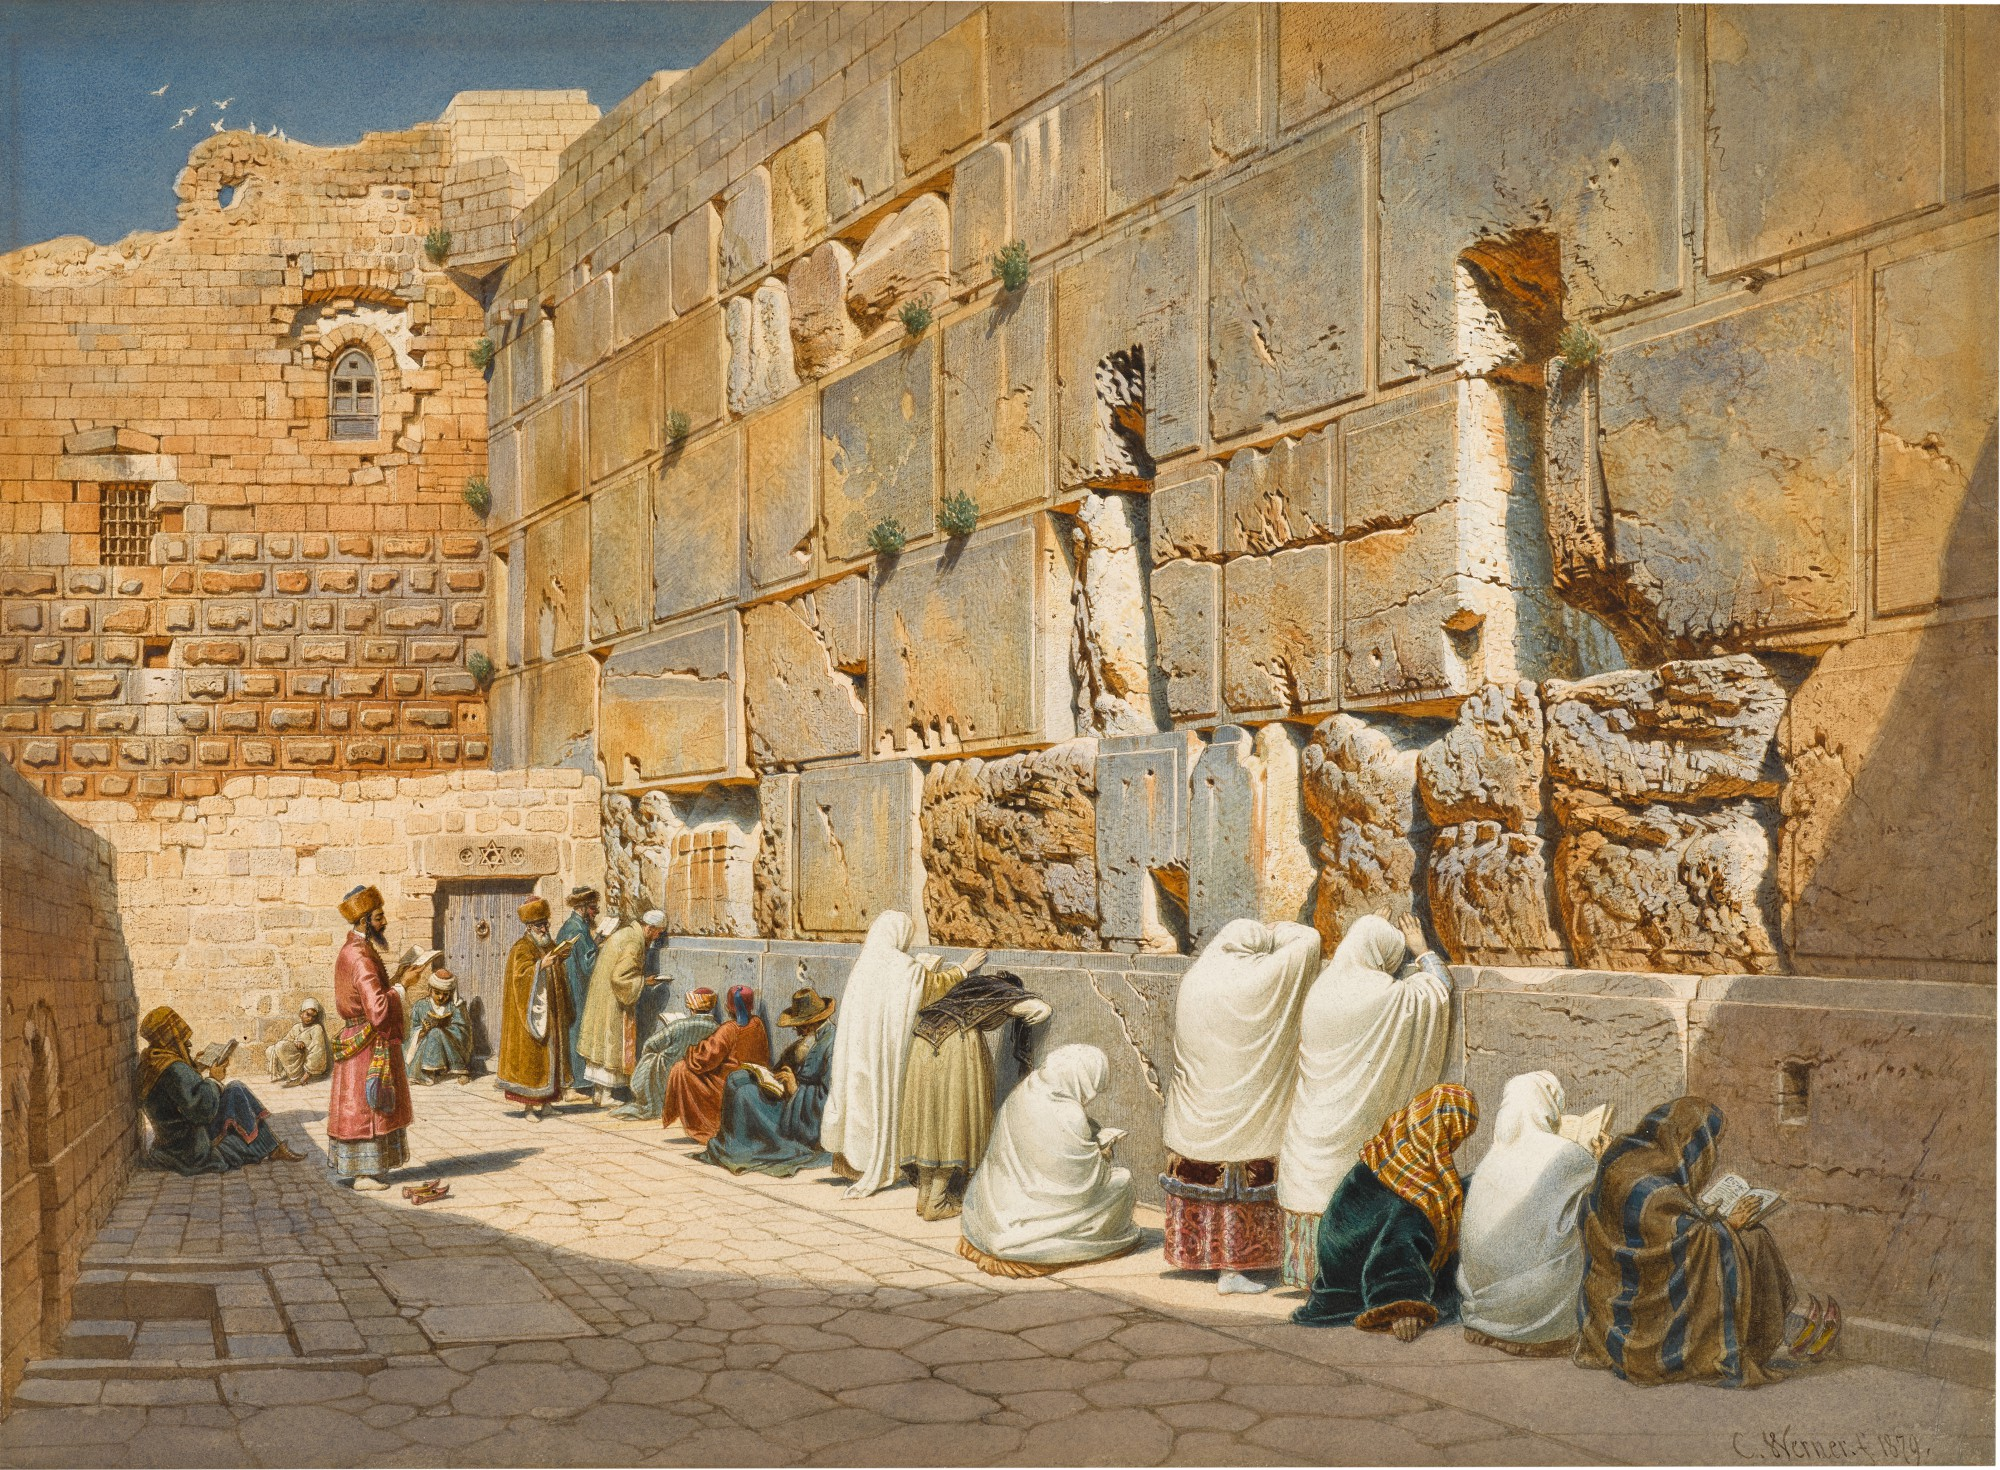What is this photo about? The image depicts the Wailing Wall, also known as the Western Wall, located in Jerusalem. This significant historical and religious site shows a number of individuals engaged in prayer and contemplation. The wall, made from ancient, weathered stones, stands as a testament to centuries of history, bearing witness to countless personal and communal prayers. The people, dressed in a mix of traditional and more contemporary garments, reflect the cultural diversity of those who visit this sacred place. The clarity of the sunlight and shadows in the image highlight the textures of the stones and the varied expressions of devotion and reflection among the figures, offering a deeply human perspective on this revered location. 